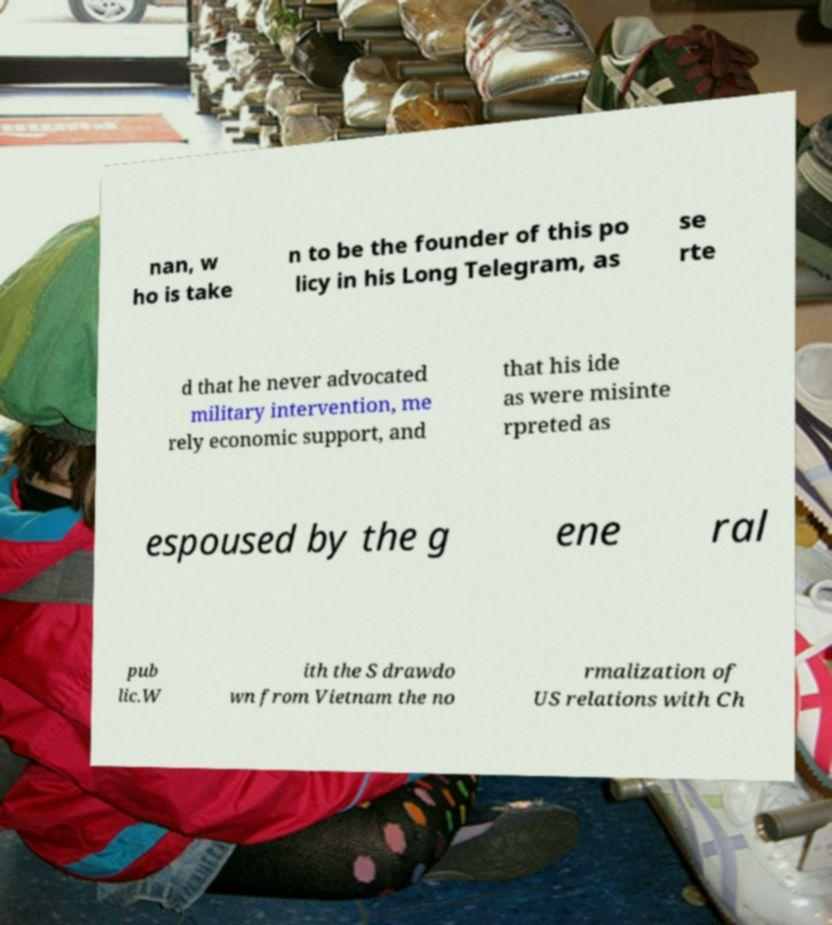Could you assist in decoding the text presented in this image and type it out clearly? nan, w ho is take n to be the founder of this po licy in his Long Telegram, as se rte d that he never advocated military intervention, me rely economic support, and that his ide as were misinte rpreted as espoused by the g ene ral pub lic.W ith the S drawdo wn from Vietnam the no rmalization of US relations with Ch 